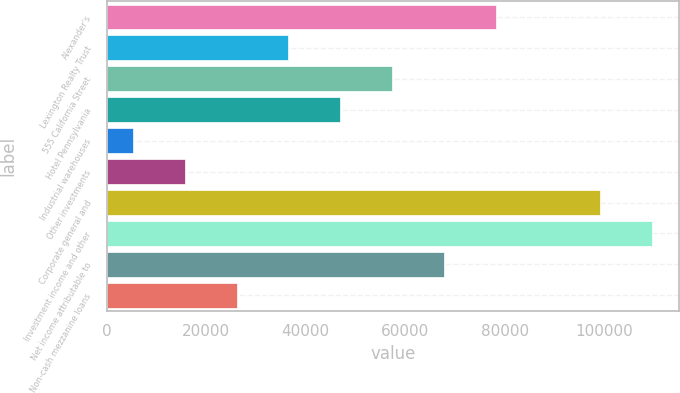Convert chart. <chart><loc_0><loc_0><loc_500><loc_500><bar_chart><fcel>Alexander's<fcel>Lexington Realty Trust<fcel>555 California Street<fcel>Hotel Pennsylvania<fcel>Industrial warehouses<fcel>Other investments<fcel>Corporate general and<fcel>Investment income and other<fcel>Net income attributable to<fcel>Non-cash mezzanine loans<nl><fcel>78242.5<fcel>36540.5<fcel>57391.5<fcel>46966<fcel>5264<fcel>15689.5<fcel>99093.5<fcel>109519<fcel>67817<fcel>26115<nl></chart> 